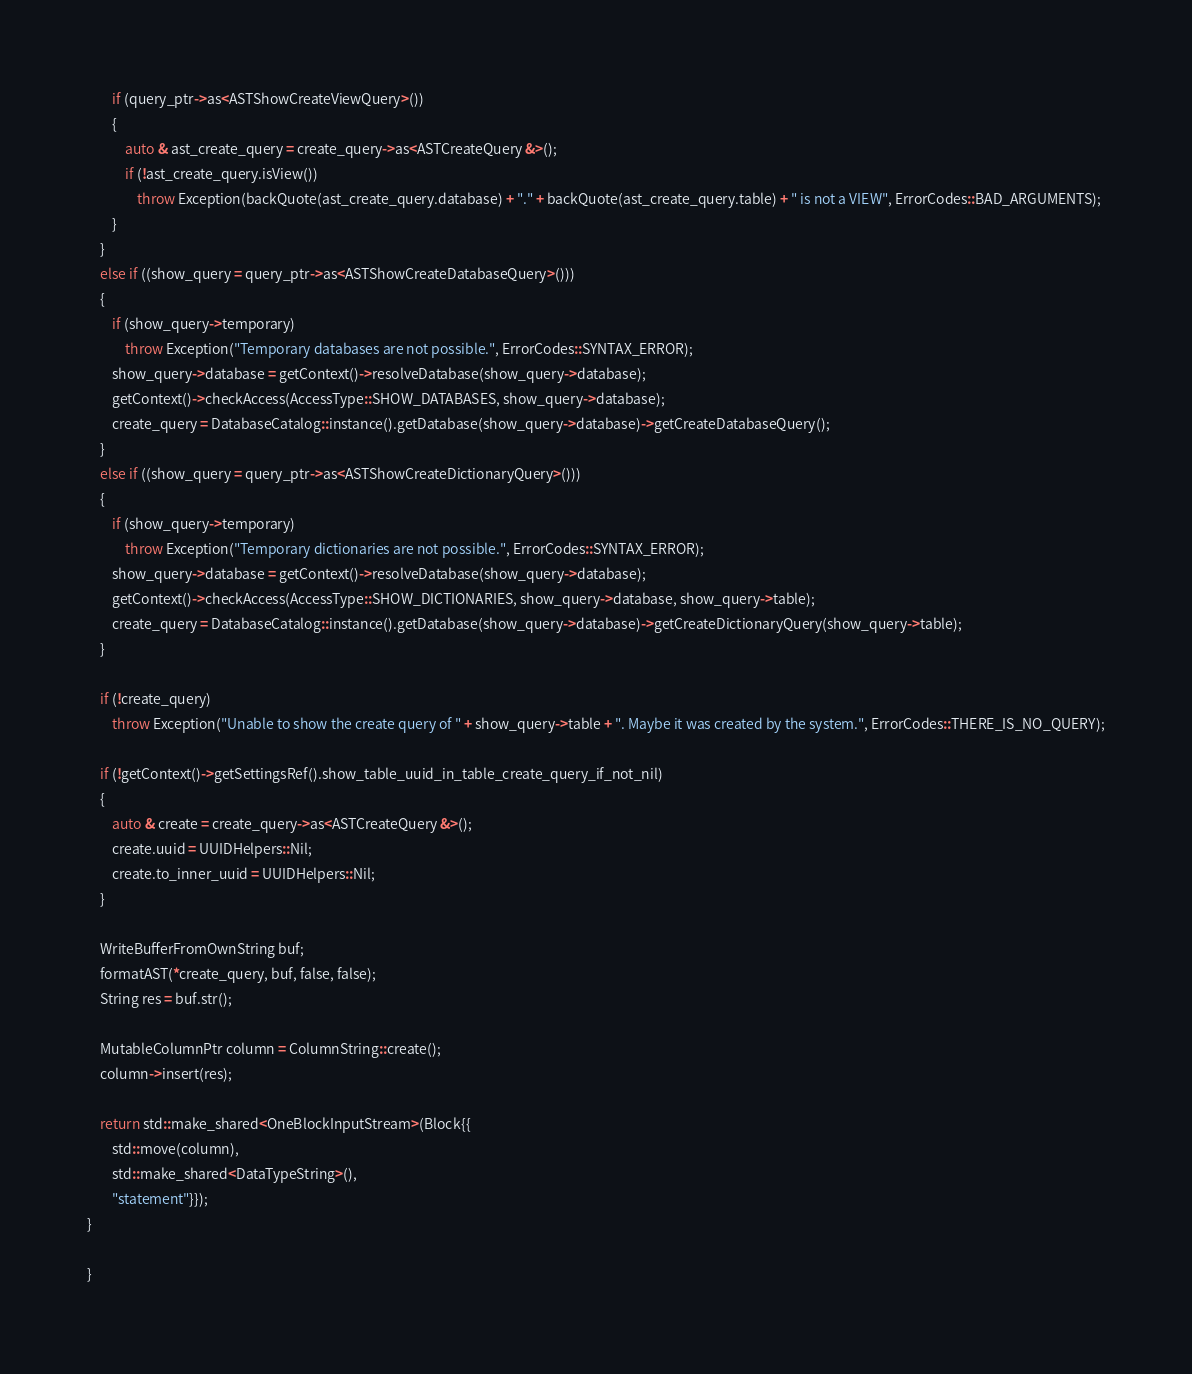Convert code to text. <code><loc_0><loc_0><loc_500><loc_500><_C++_>        if (query_ptr->as<ASTShowCreateViewQuery>())
        {
            auto & ast_create_query = create_query->as<ASTCreateQuery &>();
            if (!ast_create_query.isView())
                throw Exception(backQuote(ast_create_query.database) + "." + backQuote(ast_create_query.table) + " is not a VIEW", ErrorCodes::BAD_ARGUMENTS);
        }
    }
    else if ((show_query = query_ptr->as<ASTShowCreateDatabaseQuery>()))
    {
        if (show_query->temporary)
            throw Exception("Temporary databases are not possible.", ErrorCodes::SYNTAX_ERROR);
        show_query->database = getContext()->resolveDatabase(show_query->database);
        getContext()->checkAccess(AccessType::SHOW_DATABASES, show_query->database);
        create_query = DatabaseCatalog::instance().getDatabase(show_query->database)->getCreateDatabaseQuery();
    }
    else if ((show_query = query_ptr->as<ASTShowCreateDictionaryQuery>()))
    {
        if (show_query->temporary)
            throw Exception("Temporary dictionaries are not possible.", ErrorCodes::SYNTAX_ERROR);
        show_query->database = getContext()->resolveDatabase(show_query->database);
        getContext()->checkAccess(AccessType::SHOW_DICTIONARIES, show_query->database, show_query->table);
        create_query = DatabaseCatalog::instance().getDatabase(show_query->database)->getCreateDictionaryQuery(show_query->table);
    }

    if (!create_query)
        throw Exception("Unable to show the create query of " + show_query->table + ". Maybe it was created by the system.", ErrorCodes::THERE_IS_NO_QUERY);

    if (!getContext()->getSettingsRef().show_table_uuid_in_table_create_query_if_not_nil)
    {
        auto & create = create_query->as<ASTCreateQuery &>();
        create.uuid = UUIDHelpers::Nil;
        create.to_inner_uuid = UUIDHelpers::Nil;
    }

    WriteBufferFromOwnString buf;
    formatAST(*create_query, buf, false, false);
    String res = buf.str();

    MutableColumnPtr column = ColumnString::create();
    column->insert(res);

    return std::make_shared<OneBlockInputStream>(Block{{
        std::move(column),
        std::make_shared<DataTypeString>(),
        "statement"}});
}

}
</code> 